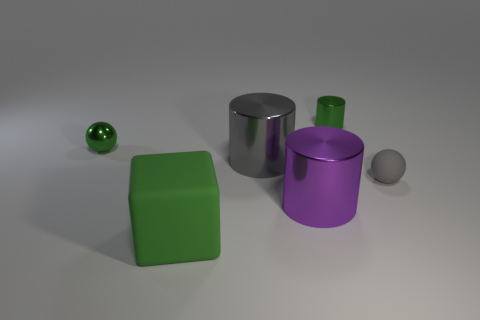What number of objects are both on the right side of the green metal cylinder and on the left side of the purple object?
Provide a succinct answer. 0. There is a green thing in front of the sphere to the left of the large cylinder that is behind the purple shiny cylinder; what is it made of?
Provide a succinct answer. Rubber. What number of green cylinders have the same material as the large purple cylinder?
Offer a very short reply. 1. What is the shape of the small metal object that is the same color as the small metallic cylinder?
Your answer should be compact. Sphere. What is the shape of the purple shiny thing that is the same size as the block?
Offer a terse response. Cylinder. There is a ball that is the same color as the cube; what material is it?
Your answer should be compact. Metal. There is a purple cylinder; are there any green metal objects to the left of it?
Keep it short and to the point. Yes. Are there any big cyan rubber things of the same shape as the small gray rubber object?
Ensure brevity in your answer.  No. There is a green thing that is right of the purple cylinder; is its shape the same as the thing left of the matte cube?
Your response must be concise. No. Is there a brown rubber cylinder that has the same size as the metal ball?
Ensure brevity in your answer.  No. 